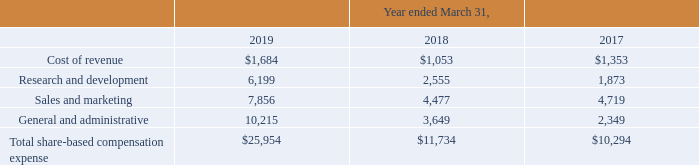11. Share-Based Compensation
As of March 31, 2019, the Company has four share-based compensation plans and an employee share purchase plan. Prior to the Company’s initial public offering (IPO) in November 2015, the Company granted share-based awards under three share option plans, which were the Mimecast Limited 2007 Key Employee Share Option Plan (the 2007 Plan), the Mimecast Limited 2010 EMI Share Option Scheme (the 2010 Plan), and the Mimecast Limited Approved Share Option Plan (the Approved Plan) (the 2007 Plan, the 2010 Plan and the Approved Plan, collectively, the Historical Plans).
Upon the closing of the IPO, the Mimecast Limited 2015 Share Option and Incentive Plan (the 2015 Plan) and the 2015 Employee Share Purchase Plan (the ESPP) became effective. Subsequent to the IPO, grants of share-based awards have been made under the 2015 Plan and no further grants under the Historical Plans are permitted.
The 2015 Plan allows the compensation committee to make equity-based incentive awards to our officers, employees, non-employee directors and consultants. Initially a total of 5.5 million ordinary shares were reserved for the issuance of awards under the 2015 Plan. This number is subject to adjustment in the event of a share split, share dividend or other change in our capitalization.
The 2015 Plan provides that the number of shares reserved and available for issuance under the plan will automatically increase each January 1st by 5% of the outstanding number of ordinary shares on the immediately preceding December 31 or such lesser number of shares as determined by the board of directors.
Under the 2015 Plan, the share option price may not be less than the fair market value of the ordinary shares on the date of grant and the term of each share option may not exceed 10 years from the date of grant. Share options typically vest over 4 years, but vesting provisions can vary based on the discretion of the board of directors.
The Company settles share option exercises under the 2015 Plan through newly issued shares. The Company’s ordinary shares underlying any awards that are forfeited, canceled, withheld upon exercise of an option, or settlement of an award to cover the exercise price or tax withholding, or otherwise terminated other than by exercise will be added back to the shares available for issuance under the 2015 Plan.
Initially, a total of 1.1 million shares of the Company's ordinary shares were reserved for future issuance under the ESPP. This number is subject to change in the event of a share split, share dividend or other change in capitalization. The ESPP may be terminated or amended by the board of directors at any time.
The ESPP permits eligible employees to purchase shares by authorizing payroll deductions from 1% to 10% of his or her eligible compensation during an offering period, a duration of six months. Unless an employee has previously withdrawn from the offering, his or her accumulated payroll deductions will be used to purchase shares on the last day of the offering period at a price equal to 85% of the fair market value of the shares on the first business day or last business day of the offering period, whichever is lower.
Share-based compensation expense recognized under the 2015 Plan, Historical Plans and ESPP in the accompanying consolidated statements of operations was as follows:
In certain situations, the board of directors has approved modifications to employee share option agreements, including acceleration of vesting or the removal of exercise restrictions for share options for which the service-based vesting has been satisfied, which resulted in additional share-based compensation expense. The total modification expense in the years ended March 31, 2019, 2018 and 2017 was $3.2 million, $0.5 million and $3.0 million, respectively.
What was the Total share-based compensation expense in 2019? $25,954. What became effective upon the closing of the IPO? The mimecast limited 2015 share option and incentive plan (the 2015 plan) and the 2015 employee share purchase plan (the espp). How much was the total modification expense in the years ended March 31, 2019, 2018 and 2017 respectively? $3.2 million, $0.5 million, $3.0 million. What is the change in Cost of revenue from Year Ending March 31, 2018 to 2019? 1,684-1,053
Answer: 631. What is the change in Research and development expense from Year Ending March 31, 2018 to 2019? 6,199-2,555
Answer: 3644. What is the change in Sales and marketing expense from Year Ending March 31, 2018 to 2019? 7,856-4,477
Answer: 3379. 